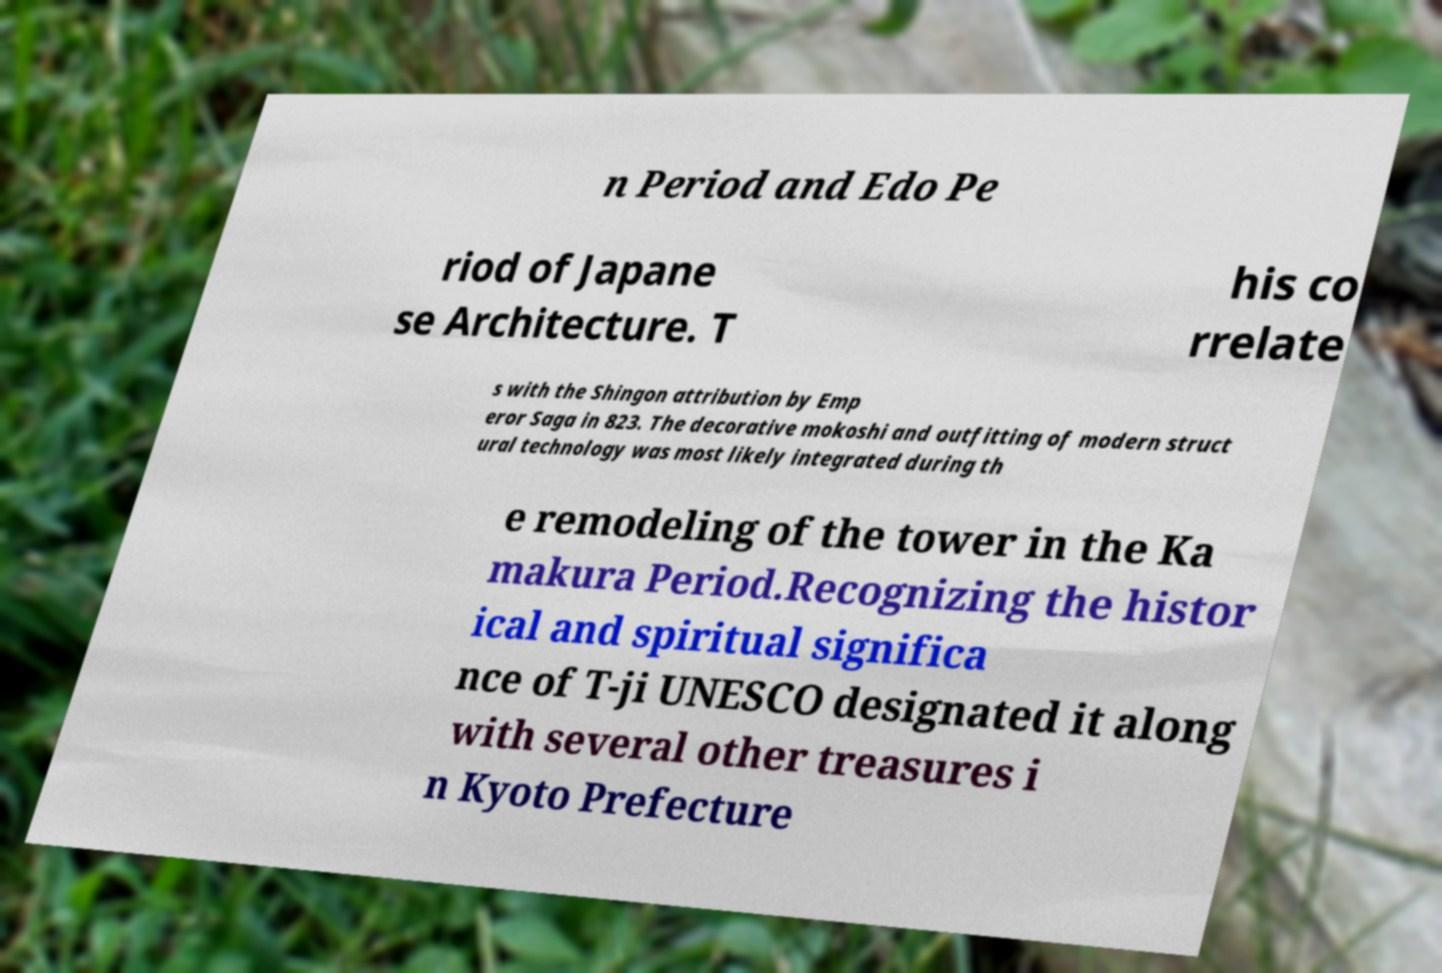Please identify and transcribe the text found in this image. n Period and Edo Pe riod of Japane se Architecture. T his co rrelate s with the Shingon attribution by Emp eror Saga in 823. The decorative mokoshi and outfitting of modern struct ural technology was most likely integrated during th e remodeling of the tower in the Ka makura Period.Recognizing the histor ical and spiritual significa nce of T-ji UNESCO designated it along with several other treasures i n Kyoto Prefecture 